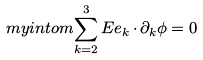<formula> <loc_0><loc_0><loc_500><loc_500>\ m y i n t o m { \sum _ { k = 2 } ^ { 3 } E e _ { k } { \, \cdot \, } \partial _ { k } \phi } = 0</formula> 